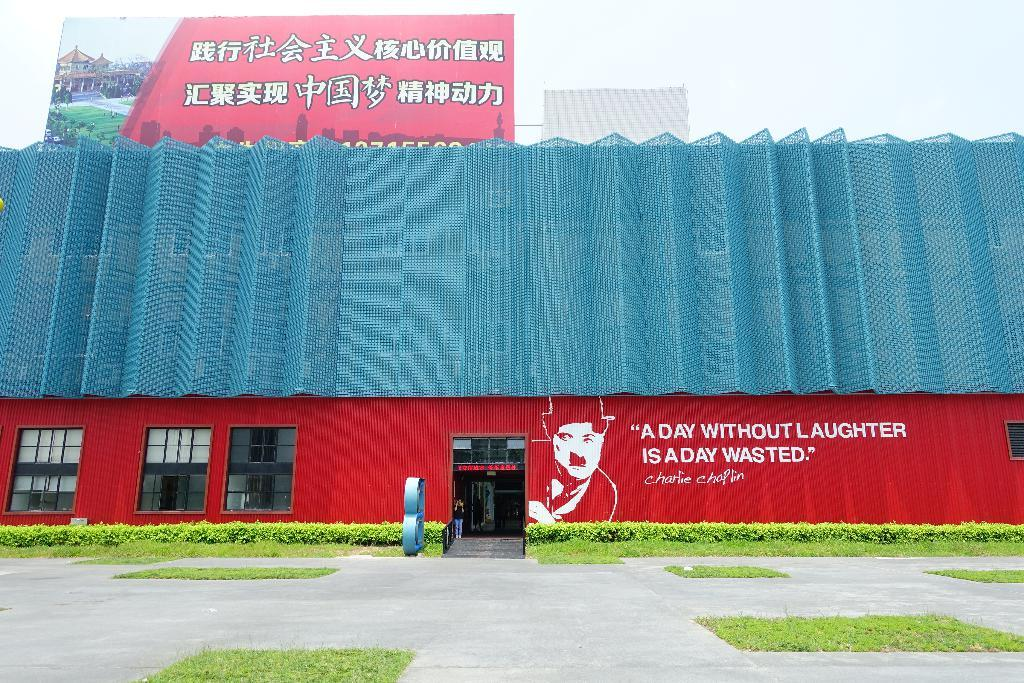What type of structure is present in the image? There is a building in the image. What feature can be seen on the building? The building has windows. What additional element is present in the image? There is a banner in the image. What type of natural environment is visible in the image? There are trees and grass in the image. What type of path is present in the image? There is a path in the image. What can be seen in the background of the image? The sky is visible in the background of the image. How many records can be seen stacked on the banner in the image? There are no records present in the image; the banner is the only item mentioned in the facts. 